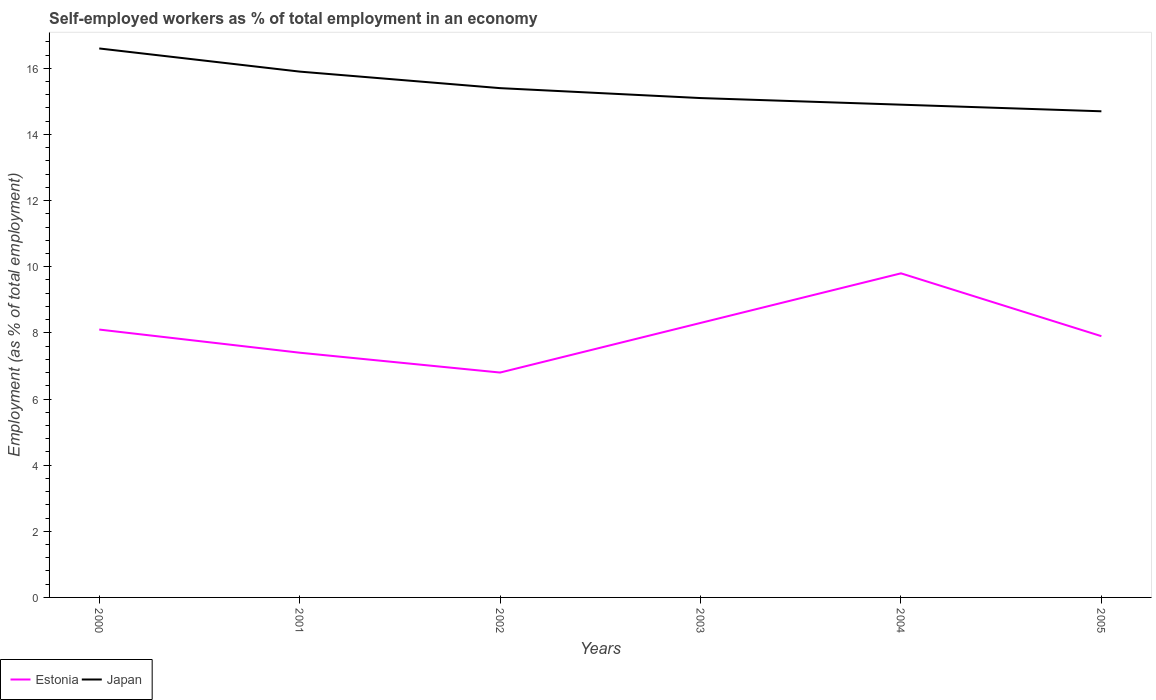Is the number of lines equal to the number of legend labels?
Ensure brevity in your answer.  Yes. Across all years, what is the maximum percentage of self-employed workers in Estonia?
Ensure brevity in your answer.  6.8. What is the total percentage of self-employed workers in Japan in the graph?
Your response must be concise. 0.4. What is the difference between the highest and the second highest percentage of self-employed workers in Estonia?
Offer a terse response. 3. Is the percentage of self-employed workers in Japan strictly greater than the percentage of self-employed workers in Estonia over the years?
Your answer should be compact. No. How many lines are there?
Give a very brief answer. 2. How many years are there in the graph?
Give a very brief answer. 6. Are the values on the major ticks of Y-axis written in scientific E-notation?
Keep it short and to the point. No. Does the graph contain grids?
Your answer should be compact. No. How are the legend labels stacked?
Your response must be concise. Horizontal. What is the title of the graph?
Make the answer very short. Self-employed workers as % of total employment in an economy. What is the label or title of the X-axis?
Make the answer very short. Years. What is the label or title of the Y-axis?
Give a very brief answer. Employment (as % of total employment). What is the Employment (as % of total employment) in Estonia in 2000?
Ensure brevity in your answer.  8.1. What is the Employment (as % of total employment) of Japan in 2000?
Provide a succinct answer. 16.6. What is the Employment (as % of total employment) in Estonia in 2001?
Offer a very short reply. 7.4. What is the Employment (as % of total employment) in Japan in 2001?
Provide a short and direct response. 15.9. What is the Employment (as % of total employment) of Estonia in 2002?
Your answer should be compact. 6.8. What is the Employment (as % of total employment) of Japan in 2002?
Your response must be concise. 15.4. What is the Employment (as % of total employment) in Estonia in 2003?
Provide a short and direct response. 8.3. What is the Employment (as % of total employment) in Japan in 2003?
Make the answer very short. 15.1. What is the Employment (as % of total employment) in Estonia in 2004?
Provide a succinct answer. 9.8. What is the Employment (as % of total employment) of Japan in 2004?
Your answer should be compact. 14.9. What is the Employment (as % of total employment) of Estonia in 2005?
Your response must be concise. 7.9. What is the Employment (as % of total employment) in Japan in 2005?
Make the answer very short. 14.7. Across all years, what is the maximum Employment (as % of total employment) in Estonia?
Keep it short and to the point. 9.8. Across all years, what is the maximum Employment (as % of total employment) of Japan?
Your response must be concise. 16.6. Across all years, what is the minimum Employment (as % of total employment) of Estonia?
Offer a very short reply. 6.8. Across all years, what is the minimum Employment (as % of total employment) of Japan?
Ensure brevity in your answer.  14.7. What is the total Employment (as % of total employment) of Estonia in the graph?
Provide a succinct answer. 48.3. What is the total Employment (as % of total employment) of Japan in the graph?
Offer a terse response. 92.6. What is the difference between the Employment (as % of total employment) in Estonia in 2000 and that in 2002?
Provide a succinct answer. 1.3. What is the difference between the Employment (as % of total employment) of Japan in 2000 and that in 2002?
Offer a very short reply. 1.2. What is the difference between the Employment (as % of total employment) of Japan in 2000 and that in 2004?
Offer a terse response. 1.7. What is the difference between the Employment (as % of total employment) of Estonia in 2000 and that in 2005?
Make the answer very short. 0.2. What is the difference between the Employment (as % of total employment) of Japan in 2000 and that in 2005?
Your response must be concise. 1.9. What is the difference between the Employment (as % of total employment) of Estonia in 2001 and that in 2002?
Your response must be concise. 0.6. What is the difference between the Employment (as % of total employment) in Japan in 2001 and that in 2002?
Offer a very short reply. 0.5. What is the difference between the Employment (as % of total employment) of Japan in 2001 and that in 2003?
Your answer should be very brief. 0.8. What is the difference between the Employment (as % of total employment) in Estonia in 2001 and that in 2004?
Keep it short and to the point. -2.4. What is the difference between the Employment (as % of total employment) of Estonia in 2001 and that in 2005?
Provide a short and direct response. -0.5. What is the difference between the Employment (as % of total employment) of Japan in 2001 and that in 2005?
Ensure brevity in your answer.  1.2. What is the difference between the Employment (as % of total employment) of Japan in 2002 and that in 2003?
Provide a succinct answer. 0.3. What is the difference between the Employment (as % of total employment) of Estonia in 2002 and that in 2004?
Keep it short and to the point. -3. What is the difference between the Employment (as % of total employment) of Japan in 2002 and that in 2004?
Give a very brief answer. 0.5. What is the difference between the Employment (as % of total employment) of Estonia in 2002 and that in 2005?
Make the answer very short. -1.1. What is the difference between the Employment (as % of total employment) in Japan in 2003 and that in 2005?
Provide a short and direct response. 0.4. What is the difference between the Employment (as % of total employment) of Estonia in 2004 and that in 2005?
Your response must be concise. 1.9. What is the difference between the Employment (as % of total employment) in Estonia in 2000 and the Employment (as % of total employment) in Japan in 2001?
Offer a terse response. -7.8. What is the difference between the Employment (as % of total employment) of Estonia in 2000 and the Employment (as % of total employment) of Japan in 2002?
Keep it short and to the point. -7.3. What is the difference between the Employment (as % of total employment) of Estonia in 2000 and the Employment (as % of total employment) of Japan in 2005?
Ensure brevity in your answer.  -6.6. What is the difference between the Employment (as % of total employment) in Estonia in 2001 and the Employment (as % of total employment) in Japan in 2003?
Keep it short and to the point. -7.7. What is the difference between the Employment (as % of total employment) of Estonia in 2001 and the Employment (as % of total employment) of Japan in 2004?
Your response must be concise. -7.5. What is the difference between the Employment (as % of total employment) in Estonia in 2001 and the Employment (as % of total employment) in Japan in 2005?
Ensure brevity in your answer.  -7.3. What is the difference between the Employment (as % of total employment) in Estonia in 2002 and the Employment (as % of total employment) in Japan in 2003?
Your answer should be very brief. -8.3. What is the difference between the Employment (as % of total employment) in Estonia in 2002 and the Employment (as % of total employment) in Japan in 2004?
Your answer should be compact. -8.1. What is the difference between the Employment (as % of total employment) in Estonia in 2002 and the Employment (as % of total employment) in Japan in 2005?
Your response must be concise. -7.9. What is the difference between the Employment (as % of total employment) of Estonia in 2003 and the Employment (as % of total employment) of Japan in 2004?
Keep it short and to the point. -6.6. What is the difference between the Employment (as % of total employment) of Estonia in 2003 and the Employment (as % of total employment) of Japan in 2005?
Make the answer very short. -6.4. What is the difference between the Employment (as % of total employment) of Estonia in 2004 and the Employment (as % of total employment) of Japan in 2005?
Provide a succinct answer. -4.9. What is the average Employment (as % of total employment) in Estonia per year?
Your answer should be very brief. 8.05. What is the average Employment (as % of total employment) of Japan per year?
Provide a short and direct response. 15.43. In the year 2000, what is the difference between the Employment (as % of total employment) of Estonia and Employment (as % of total employment) of Japan?
Keep it short and to the point. -8.5. In the year 2001, what is the difference between the Employment (as % of total employment) in Estonia and Employment (as % of total employment) in Japan?
Give a very brief answer. -8.5. In the year 2002, what is the difference between the Employment (as % of total employment) in Estonia and Employment (as % of total employment) in Japan?
Make the answer very short. -8.6. In the year 2004, what is the difference between the Employment (as % of total employment) in Estonia and Employment (as % of total employment) in Japan?
Ensure brevity in your answer.  -5.1. In the year 2005, what is the difference between the Employment (as % of total employment) of Estonia and Employment (as % of total employment) of Japan?
Offer a very short reply. -6.8. What is the ratio of the Employment (as % of total employment) in Estonia in 2000 to that in 2001?
Your response must be concise. 1.09. What is the ratio of the Employment (as % of total employment) of Japan in 2000 to that in 2001?
Give a very brief answer. 1.04. What is the ratio of the Employment (as % of total employment) of Estonia in 2000 to that in 2002?
Provide a short and direct response. 1.19. What is the ratio of the Employment (as % of total employment) of Japan in 2000 to that in 2002?
Your answer should be compact. 1.08. What is the ratio of the Employment (as % of total employment) of Estonia in 2000 to that in 2003?
Your answer should be very brief. 0.98. What is the ratio of the Employment (as % of total employment) in Japan in 2000 to that in 2003?
Make the answer very short. 1.1. What is the ratio of the Employment (as % of total employment) of Estonia in 2000 to that in 2004?
Your answer should be very brief. 0.83. What is the ratio of the Employment (as % of total employment) of Japan in 2000 to that in 2004?
Your answer should be very brief. 1.11. What is the ratio of the Employment (as % of total employment) of Estonia in 2000 to that in 2005?
Offer a terse response. 1.03. What is the ratio of the Employment (as % of total employment) in Japan in 2000 to that in 2005?
Keep it short and to the point. 1.13. What is the ratio of the Employment (as % of total employment) in Estonia in 2001 to that in 2002?
Provide a succinct answer. 1.09. What is the ratio of the Employment (as % of total employment) of Japan in 2001 to that in 2002?
Your answer should be compact. 1.03. What is the ratio of the Employment (as % of total employment) in Estonia in 2001 to that in 2003?
Keep it short and to the point. 0.89. What is the ratio of the Employment (as % of total employment) in Japan in 2001 to that in 2003?
Offer a very short reply. 1.05. What is the ratio of the Employment (as % of total employment) in Estonia in 2001 to that in 2004?
Provide a succinct answer. 0.76. What is the ratio of the Employment (as % of total employment) in Japan in 2001 to that in 2004?
Your answer should be compact. 1.07. What is the ratio of the Employment (as % of total employment) of Estonia in 2001 to that in 2005?
Offer a very short reply. 0.94. What is the ratio of the Employment (as % of total employment) in Japan in 2001 to that in 2005?
Ensure brevity in your answer.  1.08. What is the ratio of the Employment (as % of total employment) of Estonia in 2002 to that in 2003?
Give a very brief answer. 0.82. What is the ratio of the Employment (as % of total employment) in Japan in 2002 to that in 2003?
Give a very brief answer. 1.02. What is the ratio of the Employment (as % of total employment) of Estonia in 2002 to that in 2004?
Provide a succinct answer. 0.69. What is the ratio of the Employment (as % of total employment) of Japan in 2002 to that in 2004?
Give a very brief answer. 1.03. What is the ratio of the Employment (as % of total employment) of Estonia in 2002 to that in 2005?
Offer a very short reply. 0.86. What is the ratio of the Employment (as % of total employment) in Japan in 2002 to that in 2005?
Your answer should be compact. 1.05. What is the ratio of the Employment (as % of total employment) of Estonia in 2003 to that in 2004?
Your answer should be compact. 0.85. What is the ratio of the Employment (as % of total employment) of Japan in 2003 to that in 2004?
Your answer should be compact. 1.01. What is the ratio of the Employment (as % of total employment) of Estonia in 2003 to that in 2005?
Ensure brevity in your answer.  1.05. What is the ratio of the Employment (as % of total employment) of Japan in 2003 to that in 2005?
Offer a very short reply. 1.03. What is the ratio of the Employment (as % of total employment) in Estonia in 2004 to that in 2005?
Your answer should be compact. 1.24. What is the ratio of the Employment (as % of total employment) in Japan in 2004 to that in 2005?
Ensure brevity in your answer.  1.01. 